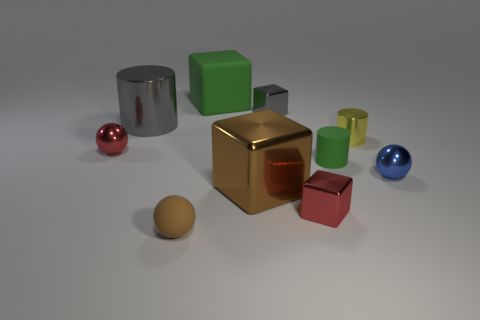Subtract 1 cubes. How many cubes are left? 3 Subtract all spheres. How many objects are left? 7 Add 4 small blue things. How many small blue things exist? 5 Subtract 0 cyan cylinders. How many objects are left? 10 Subtract all tiny green shiny objects. Subtract all big cubes. How many objects are left? 8 Add 3 small red metal blocks. How many small red metal blocks are left? 4 